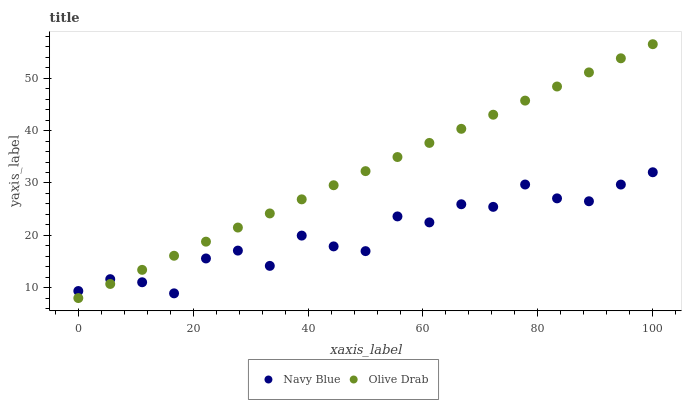Does Navy Blue have the minimum area under the curve?
Answer yes or no. Yes. Does Olive Drab have the maximum area under the curve?
Answer yes or no. Yes. Does Olive Drab have the minimum area under the curve?
Answer yes or no. No. Is Olive Drab the smoothest?
Answer yes or no. Yes. Is Navy Blue the roughest?
Answer yes or no. Yes. Is Olive Drab the roughest?
Answer yes or no. No. Does Olive Drab have the lowest value?
Answer yes or no. Yes. Does Olive Drab have the highest value?
Answer yes or no. Yes. Does Olive Drab intersect Navy Blue?
Answer yes or no. Yes. Is Olive Drab less than Navy Blue?
Answer yes or no. No. Is Olive Drab greater than Navy Blue?
Answer yes or no. No. 